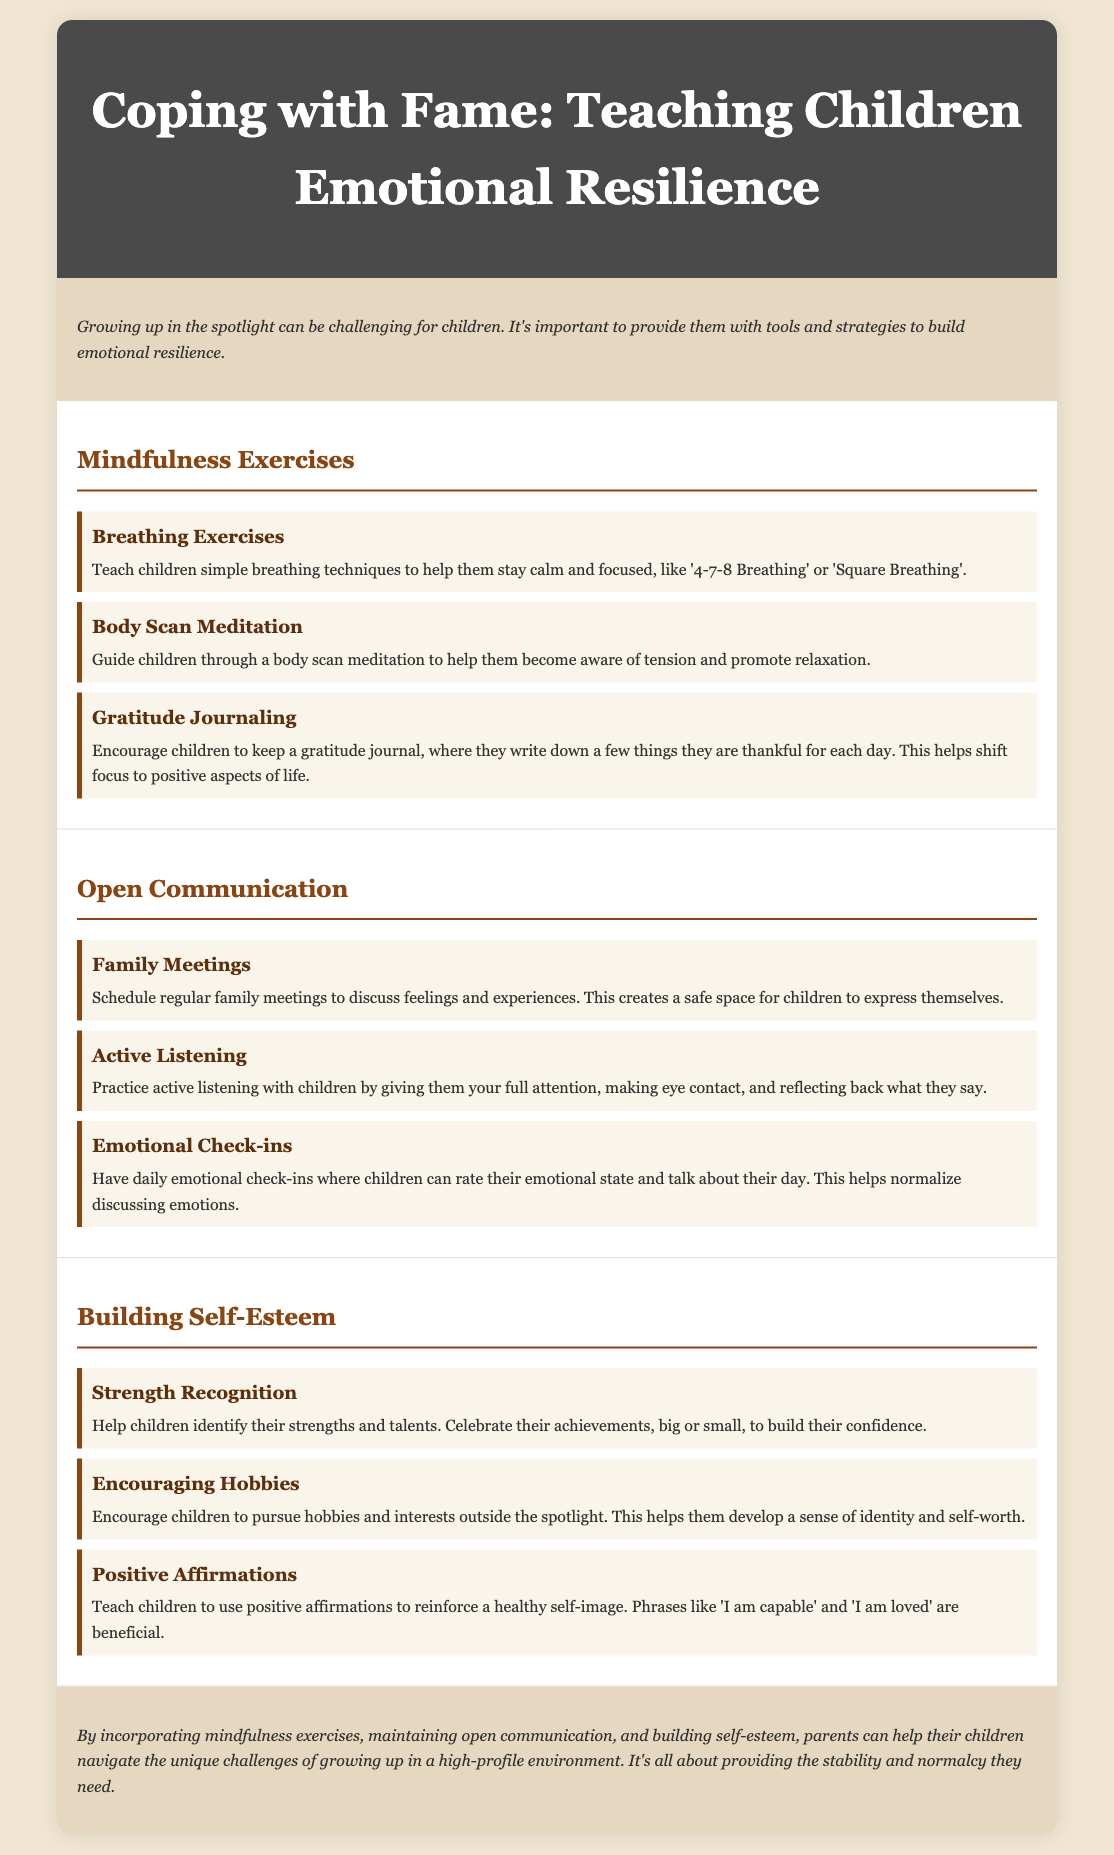What is the title of the document? The title of the document is stated in the header section at the top of the document.
Answer: Coping with Fame: Teaching Children Emotional Resilience What is one mindfulness exercise mentioned in the document? The document lists several mindfulness exercises under the "Mindfulness Exercises" section.
Answer: Breathing Exercises How can parents facilitate open communication? The document provides specific strategies within the "Open Communication" section for fostering dialogue.
Answer: Family Meetings What activity helps children to identify their strengths? The document suggests specific activities to help build self-esteem in children within the "Building Self-Esteem" section.
Answer: Strength Recognition What is the purpose of gratitude journaling? The document explains the purpose of gratitude journaling within the context of mindfulness exercises.
Answer: Shift focus to positive aspects of life How many sections are there in the document? The document is divided into specific sections to organize the information effectively.
Answer: Three 